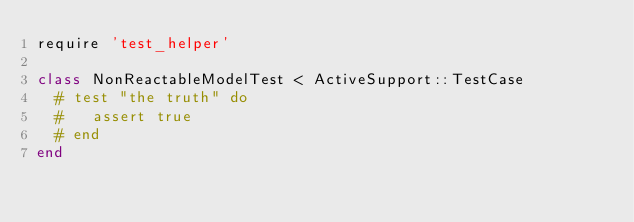<code> <loc_0><loc_0><loc_500><loc_500><_Ruby_>require 'test_helper'

class NonReactableModelTest < ActiveSupport::TestCase
  # test "the truth" do
  #   assert true
  # end
end
</code> 